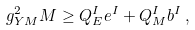Convert formula to latex. <formula><loc_0><loc_0><loc_500><loc_500>g _ { Y M } ^ { 2 } M \geq Q _ { E } ^ { I } e ^ { I } + Q _ { M } ^ { I } b ^ { I } \, ,</formula> 